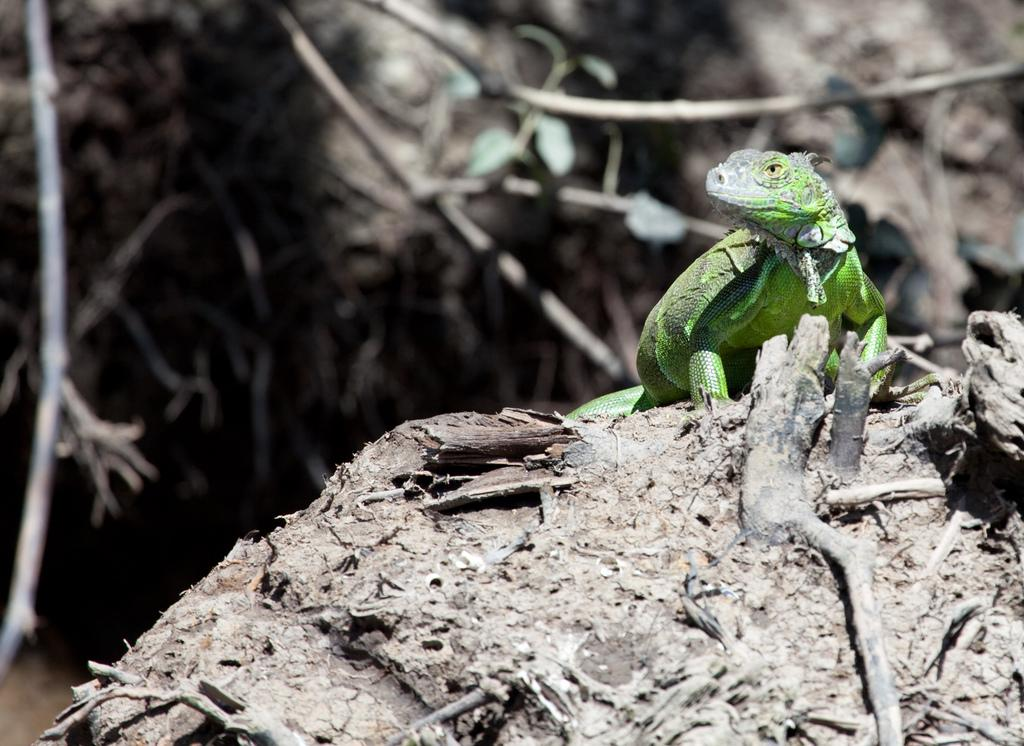What is located at the bottom of the image? There is a tree at the bottom of the image. What can be seen on the tree? There is a reptile on the tree. What type of vegetation is visible in the background of the image? There are trees visible in the background of the image. Can you hear your uncle talking to the jellyfish in the image? There is no uncle or jellyfish present in the image, so it is not possible to hear them talking. 